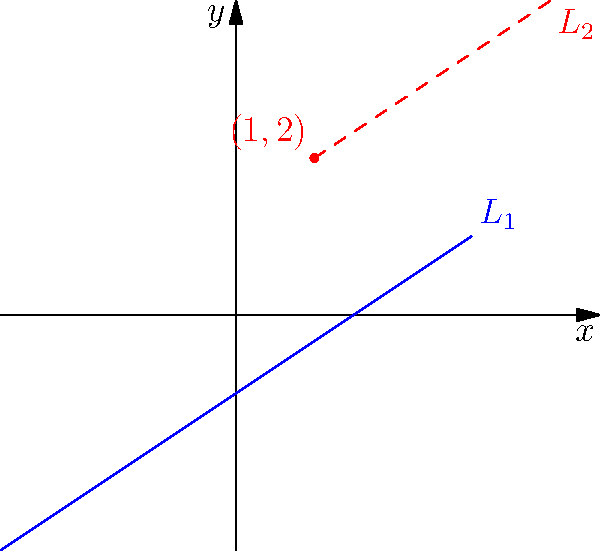In a recent case involving disputed property boundaries, you need to analyze a surveyor's map. The map shows a boundary line $L_1$ with equation $y = \frac{2}{3}x - 1$. A key landmark is located at point $(1,2)$. To resolve the dispute, you need to determine the equation of a line $L_2$ that is parallel to $L_1$ and passes through the landmark point. What is the equation of line $L_2$? Let's approach this step-by-step:

1) We know that parallel lines have the same slope. So, the slope of $L_2$ will be the same as the slope of $L_1$, which is $\frac{2}{3}$.

2) We can use the point-slope form of a line equation to find $L_2$:
   $y - y_1 = m(x - x_1)$
   where $(x_1, y_1)$ is a point on the line and $m$ is the slope.

3) We have the point $(1,2)$ and the slope $\frac{2}{3}$. Let's substitute these into the point-slope form:
   $y - 2 = \frac{2}{3}(x - 1)$

4) To get the equation into slope-intercept form $(y = mx + b)$, let's distribute the $\frac{2}{3}$:
   $y - 2 = \frac{2}{3}x - \frac{2}{3}$

5) Now, add 2 to both sides:
   $y = \frac{2}{3}x - \frac{2}{3} + 2$

6) Simplify the right side:
   $y = \frac{2}{3}x + \frac{4}{3}$

Therefore, the equation of line $L_2$ is $y = \frac{2}{3}x + \frac{4}{3}$.
Answer: $y = \frac{2}{3}x + \frac{4}{3}$ 